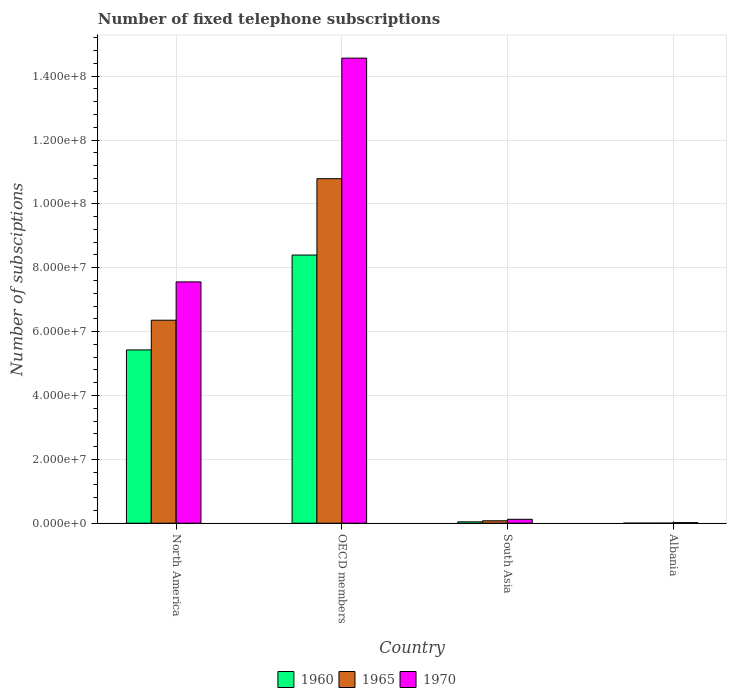How many different coloured bars are there?
Offer a terse response. 3. How many groups of bars are there?
Your response must be concise. 4. Are the number of bars per tick equal to the number of legend labels?
Your answer should be compact. Yes. Are the number of bars on each tick of the X-axis equal?
Give a very brief answer. Yes. What is the label of the 2nd group of bars from the left?
Give a very brief answer. OECD members. In how many cases, is the number of bars for a given country not equal to the number of legend labels?
Provide a short and direct response. 0. What is the number of fixed telephone subscriptions in 1970 in OECD members?
Your answer should be very brief. 1.46e+08. Across all countries, what is the maximum number of fixed telephone subscriptions in 1960?
Ensure brevity in your answer.  8.40e+07. Across all countries, what is the minimum number of fixed telephone subscriptions in 1965?
Offer a very short reply. 1.40e+04. In which country was the number of fixed telephone subscriptions in 1970 minimum?
Your answer should be very brief. Albania. What is the total number of fixed telephone subscriptions in 1965 in the graph?
Provide a short and direct response. 1.72e+08. What is the difference between the number of fixed telephone subscriptions in 1960 in North America and that in OECD members?
Offer a very short reply. -2.97e+07. What is the difference between the number of fixed telephone subscriptions in 1960 in OECD members and the number of fixed telephone subscriptions in 1970 in North America?
Your answer should be very brief. 8.41e+06. What is the average number of fixed telephone subscriptions in 1965 per country?
Offer a very short reply. 4.31e+07. What is the difference between the number of fixed telephone subscriptions of/in 1960 and number of fixed telephone subscriptions of/in 1970 in South Asia?
Ensure brevity in your answer.  -7.90e+05. What is the ratio of the number of fixed telephone subscriptions in 1960 in North America to that in South Asia?
Your answer should be very brief. 126.3. Is the number of fixed telephone subscriptions in 1970 in Albania less than that in South Asia?
Keep it short and to the point. Yes. What is the difference between the highest and the second highest number of fixed telephone subscriptions in 1965?
Offer a very short reply. 1.07e+08. What is the difference between the highest and the lowest number of fixed telephone subscriptions in 1970?
Offer a terse response. 1.45e+08. In how many countries, is the number of fixed telephone subscriptions in 1970 greater than the average number of fixed telephone subscriptions in 1970 taken over all countries?
Ensure brevity in your answer.  2. Is the sum of the number of fixed telephone subscriptions in 1965 in North America and OECD members greater than the maximum number of fixed telephone subscriptions in 1960 across all countries?
Offer a very short reply. Yes. What does the 3rd bar from the left in OECD members represents?
Make the answer very short. 1970. What is the difference between two consecutive major ticks on the Y-axis?
Your answer should be compact. 2.00e+07. Are the values on the major ticks of Y-axis written in scientific E-notation?
Your answer should be very brief. Yes. What is the title of the graph?
Ensure brevity in your answer.  Number of fixed telephone subscriptions. Does "1991" appear as one of the legend labels in the graph?
Provide a short and direct response. No. What is the label or title of the X-axis?
Offer a very short reply. Country. What is the label or title of the Y-axis?
Provide a short and direct response. Number of subsciptions. What is the Number of subsciptions of 1960 in North America?
Your response must be concise. 5.43e+07. What is the Number of subsciptions in 1965 in North America?
Your answer should be compact. 6.36e+07. What is the Number of subsciptions of 1970 in North America?
Your response must be concise. 7.56e+07. What is the Number of subsciptions in 1960 in OECD members?
Your answer should be very brief. 8.40e+07. What is the Number of subsciptions in 1965 in OECD members?
Offer a terse response. 1.08e+08. What is the Number of subsciptions in 1970 in OECD members?
Your answer should be compact. 1.46e+08. What is the Number of subsciptions in 1960 in South Asia?
Ensure brevity in your answer.  4.30e+05. What is the Number of subsciptions of 1965 in South Asia?
Ensure brevity in your answer.  7.57e+05. What is the Number of subsciptions in 1970 in South Asia?
Make the answer very short. 1.22e+06. What is the Number of subsciptions in 1960 in Albania?
Offer a terse response. 6845. What is the Number of subsciptions in 1965 in Albania?
Keep it short and to the point. 1.40e+04. What is the Number of subsciptions in 1970 in Albania?
Provide a short and direct response. 1.73e+05. Across all countries, what is the maximum Number of subsciptions in 1960?
Your response must be concise. 8.40e+07. Across all countries, what is the maximum Number of subsciptions of 1965?
Keep it short and to the point. 1.08e+08. Across all countries, what is the maximum Number of subsciptions of 1970?
Offer a very short reply. 1.46e+08. Across all countries, what is the minimum Number of subsciptions of 1960?
Provide a succinct answer. 6845. Across all countries, what is the minimum Number of subsciptions of 1965?
Ensure brevity in your answer.  1.40e+04. Across all countries, what is the minimum Number of subsciptions of 1970?
Make the answer very short. 1.73e+05. What is the total Number of subsciptions of 1960 in the graph?
Make the answer very short. 1.39e+08. What is the total Number of subsciptions of 1965 in the graph?
Provide a succinct answer. 1.72e+08. What is the total Number of subsciptions in 1970 in the graph?
Provide a succinct answer. 2.23e+08. What is the difference between the Number of subsciptions of 1960 in North America and that in OECD members?
Provide a short and direct response. -2.97e+07. What is the difference between the Number of subsciptions in 1965 in North America and that in OECD members?
Your answer should be compact. -4.43e+07. What is the difference between the Number of subsciptions in 1970 in North America and that in OECD members?
Ensure brevity in your answer.  -7.01e+07. What is the difference between the Number of subsciptions of 1960 in North America and that in South Asia?
Ensure brevity in your answer.  5.38e+07. What is the difference between the Number of subsciptions in 1965 in North America and that in South Asia?
Make the answer very short. 6.28e+07. What is the difference between the Number of subsciptions of 1970 in North America and that in South Asia?
Offer a very short reply. 7.43e+07. What is the difference between the Number of subsciptions of 1960 in North America and that in Albania?
Make the answer very short. 5.43e+07. What is the difference between the Number of subsciptions in 1965 in North America and that in Albania?
Provide a succinct answer. 6.36e+07. What is the difference between the Number of subsciptions in 1970 in North America and that in Albania?
Your answer should be compact. 7.54e+07. What is the difference between the Number of subsciptions of 1960 in OECD members and that in South Asia?
Give a very brief answer. 8.36e+07. What is the difference between the Number of subsciptions of 1965 in OECD members and that in South Asia?
Keep it short and to the point. 1.07e+08. What is the difference between the Number of subsciptions in 1970 in OECD members and that in South Asia?
Give a very brief answer. 1.44e+08. What is the difference between the Number of subsciptions in 1960 in OECD members and that in Albania?
Make the answer very short. 8.40e+07. What is the difference between the Number of subsciptions of 1965 in OECD members and that in Albania?
Your answer should be compact. 1.08e+08. What is the difference between the Number of subsciptions of 1970 in OECD members and that in Albania?
Your answer should be compact. 1.45e+08. What is the difference between the Number of subsciptions of 1960 in South Asia and that in Albania?
Make the answer very short. 4.23e+05. What is the difference between the Number of subsciptions of 1965 in South Asia and that in Albania?
Your response must be concise. 7.43e+05. What is the difference between the Number of subsciptions of 1970 in South Asia and that in Albania?
Provide a succinct answer. 1.05e+06. What is the difference between the Number of subsciptions in 1960 in North America and the Number of subsciptions in 1965 in OECD members?
Your response must be concise. -5.36e+07. What is the difference between the Number of subsciptions of 1960 in North America and the Number of subsciptions of 1970 in OECD members?
Your answer should be very brief. -9.14e+07. What is the difference between the Number of subsciptions in 1965 in North America and the Number of subsciptions in 1970 in OECD members?
Your answer should be very brief. -8.21e+07. What is the difference between the Number of subsciptions in 1960 in North America and the Number of subsciptions in 1965 in South Asia?
Keep it short and to the point. 5.35e+07. What is the difference between the Number of subsciptions in 1960 in North America and the Number of subsciptions in 1970 in South Asia?
Your answer should be very brief. 5.30e+07. What is the difference between the Number of subsciptions in 1965 in North America and the Number of subsciptions in 1970 in South Asia?
Offer a very short reply. 6.24e+07. What is the difference between the Number of subsciptions in 1960 in North America and the Number of subsciptions in 1965 in Albania?
Offer a very short reply. 5.43e+07. What is the difference between the Number of subsciptions of 1960 in North America and the Number of subsciptions of 1970 in Albania?
Make the answer very short. 5.41e+07. What is the difference between the Number of subsciptions in 1965 in North America and the Number of subsciptions in 1970 in Albania?
Your response must be concise. 6.34e+07. What is the difference between the Number of subsciptions in 1960 in OECD members and the Number of subsciptions in 1965 in South Asia?
Make the answer very short. 8.32e+07. What is the difference between the Number of subsciptions in 1960 in OECD members and the Number of subsciptions in 1970 in South Asia?
Provide a succinct answer. 8.28e+07. What is the difference between the Number of subsciptions of 1965 in OECD members and the Number of subsciptions of 1970 in South Asia?
Make the answer very short. 1.07e+08. What is the difference between the Number of subsciptions of 1960 in OECD members and the Number of subsciptions of 1965 in Albania?
Provide a succinct answer. 8.40e+07. What is the difference between the Number of subsciptions of 1960 in OECD members and the Number of subsciptions of 1970 in Albania?
Give a very brief answer. 8.38e+07. What is the difference between the Number of subsciptions in 1965 in OECD members and the Number of subsciptions in 1970 in Albania?
Your answer should be very brief. 1.08e+08. What is the difference between the Number of subsciptions of 1960 in South Asia and the Number of subsciptions of 1965 in Albania?
Give a very brief answer. 4.16e+05. What is the difference between the Number of subsciptions in 1960 in South Asia and the Number of subsciptions in 1970 in Albania?
Offer a terse response. 2.57e+05. What is the difference between the Number of subsciptions of 1965 in South Asia and the Number of subsciptions of 1970 in Albania?
Offer a very short reply. 5.84e+05. What is the average Number of subsciptions of 1960 per country?
Provide a succinct answer. 3.47e+07. What is the average Number of subsciptions in 1965 per country?
Give a very brief answer. 4.31e+07. What is the average Number of subsciptions in 1970 per country?
Provide a succinct answer. 5.57e+07. What is the difference between the Number of subsciptions in 1960 and Number of subsciptions in 1965 in North America?
Make the answer very short. -9.30e+06. What is the difference between the Number of subsciptions of 1960 and Number of subsciptions of 1970 in North America?
Keep it short and to the point. -2.13e+07. What is the difference between the Number of subsciptions in 1965 and Number of subsciptions in 1970 in North America?
Your answer should be compact. -1.20e+07. What is the difference between the Number of subsciptions in 1960 and Number of subsciptions in 1965 in OECD members?
Give a very brief answer. -2.39e+07. What is the difference between the Number of subsciptions in 1960 and Number of subsciptions in 1970 in OECD members?
Your answer should be compact. -6.17e+07. What is the difference between the Number of subsciptions of 1965 and Number of subsciptions of 1970 in OECD members?
Your answer should be compact. -3.78e+07. What is the difference between the Number of subsciptions of 1960 and Number of subsciptions of 1965 in South Asia?
Make the answer very short. -3.27e+05. What is the difference between the Number of subsciptions of 1960 and Number of subsciptions of 1970 in South Asia?
Offer a very short reply. -7.90e+05. What is the difference between the Number of subsciptions in 1965 and Number of subsciptions in 1970 in South Asia?
Provide a short and direct response. -4.63e+05. What is the difference between the Number of subsciptions in 1960 and Number of subsciptions in 1965 in Albania?
Give a very brief answer. -7146. What is the difference between the Number of subsciptions in 1960 and Number of subsciptions in 1970 in Albania?
Offer a terse response. -1.66e+05. What is the difference between the Number of subsciptions of 1965 and Number of subsciptions of 1970 in Albania?
Provide a short and direct response. -1.59e+05. What is the ratio of the Number of subsciptions of 1960 in North America to that in OECD members?
Provide a short and direct response. 0.65. What is the ratio of the Number of subsciptions of 1965 in North America to that in OECD members?
Your answer should be compact. 0.59. What is the ratio of the Number of subsciptions of 1970 in North America to that in OECD members?
Offer a terse response. 0.52. What is the ratio of the Number of subsciptions of 1960 in North America to that in South Asia?
Make the answer very short. 126.3. What is the ratio of the Number of subsciptions in 1965 in North America to that in South Asia?
Give a very brief answer. 84.02. What is the ratio of the Number of subsciptions in 1970 in North America to that in South Asia?
Your response must be concise. 61.94. What is the ratio of the Number of subsciptions of 1960 in North America to that in Albania?
Make the answer very short. 7927.8. What is the ratio of the Number of subsciptions in 1965 in North America to that in Albania?
Offer a terse response. 4543.67. What is the ratio of the Number of subsciptions of 1970 in North America to that in Albania?
Your answer should be very brief. 436.82. What is the ratio of the Number of subsciptions of 1960 in OECD members to that in South Asia?
Your response must be concise. 195.46. What is the ratio of the Number of subsciptions of 1965 in OECD members to that in South Asia?
Offer a very short reply. 142.6. What is the ratio of the Number of subsciptions in 1970 in OECD members to that in South Asia?
Your answer should be very brief. 119.38. What is the ratio of the Number of subsciptions of 1960 in OECD members to that in Albania?
Make the answer very short. 1.23e+04. What is the ratio of the Number of subsciptions of 1965 in OECD members to that in Albania?
Make the answer very short. 7711.94. What is the ratio of the Number of subsciptions in 1970 in OECD members to that in Albania?
Provide a succinct answer. 841.91. What is the ratio of the Number of subsciptions in 1960 in South Asia to that in Albania?
Ensure brevity in your answer.  62.77. What is the ratio of the Number of subsciptions in 1965 in South Asia to that in Albania?
Offer a terse response. 54.08. What is the ratio of the Number of subsciptions in 1970 in South Asia to that in Albania?
Provide a short and direct response. 7.05. What is the difference between the highest and the second highest Number of subsciptions in 1960?
Offer a very short reply. 2.97e+07. What is the difference between the highest and the second highest Number of subsciptions of 1965?
Ensure brevity in your answer.  4.43e+07. What is the difference between the highest and the second highest Number of subsciptions in 1970?
Your answer should be compact. 7.01e+07. What is the difference between the highest and the lowest Number of subsciptions in 1960?
Make the answer very short. 8.40e+07. What is the difference between the highest and the lowest Number of subsciptions in 1965?
Make the answer very short. 1.08e+08. What is the difference between the highest and the lowest Number of subsciptions of 1970?
Your response must be concise. 1.45e+08. 